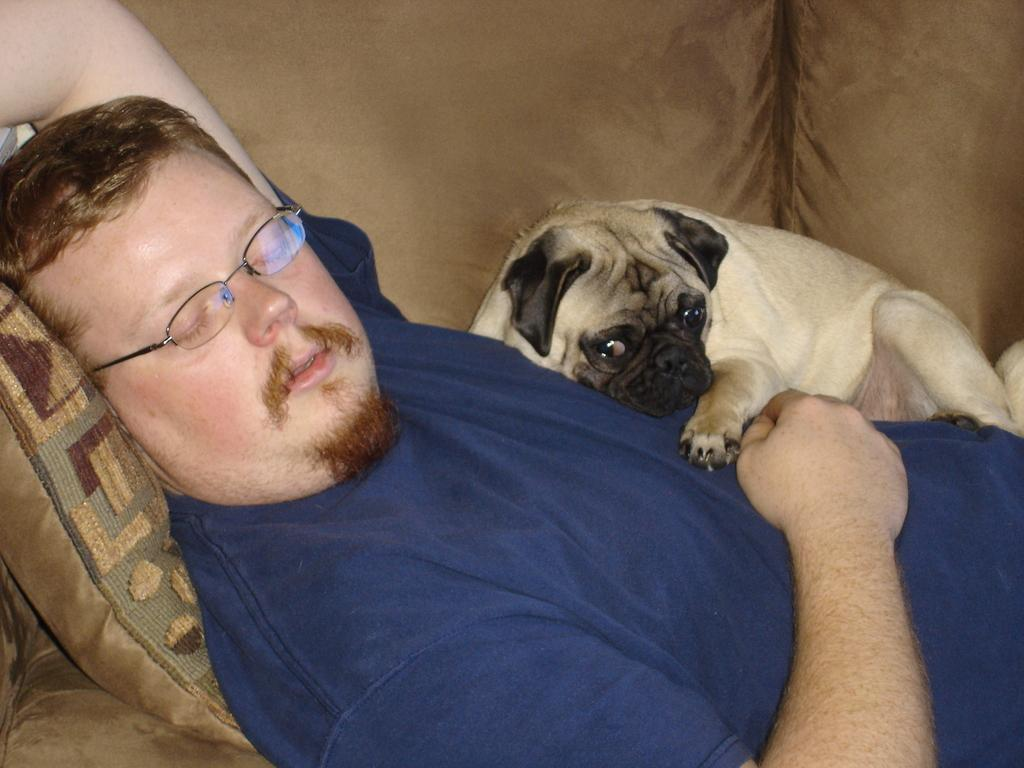What is the main subject of the image? There is a person in the image. What is the person wearing? The person is wearing a blue t-shirt. What accessory is the person wearing? The person is wearing spectacles. What is the person doing in the image? The person is sleeping. What object is present in the image that might be used for comfort while sleeping? There is a pillow in the image. What other living creature is present in the image? There is a dog in the image. How is the dog positioned in relation to the person? The dog is lying over the person. What type of plants can be seen in the image? There are no plants visible in the image. What topic is being discussed between the person and the dog in the image? There is no discussion taking place in the image, as the person is sleeping and the dog is lying over the person. 